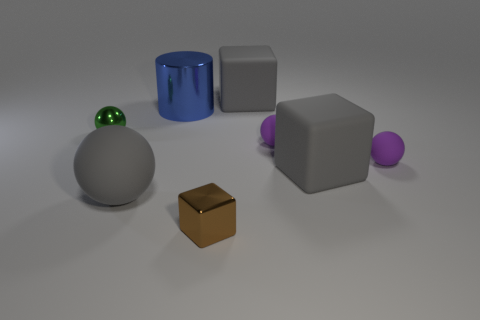There is a gray cube in front of the big blue shiny cylinder; is its size the same as the gray object that is behind the blue thing?
Make the answer very short. Yes. There is a small purple sphere on the left side of the gray block that is in front of the big metallic cylinder; what is it made of?
Your answer should be compact. Rubber. What number of objects are either spheres behind the large ball or large cylinders?
Make the answer very short. 4. Are there an equal number of large gray objects that are in front of the tiny green object and small brown metallic objects that are behind the large ball?
Your answer should be very brief. No. What is the material of the gray block that is behind the shiny object behind the tiny metallic ball that is behind the large gray ball?
Keep it short and to the point. Rubber. What is the size of the object that is left of the large blue cylinder and in front of the green shiny sphere?
Give a very brief answer. Large. What is the shape of the brown object that is made of the same material as the green sphere?
Your answer should be very brief. Cube. How many tiny things are either blue shiny things or red metallic spheres?
Your answer should be compact. 0. Is there a shiny ball right of the small object that is left of the gray ball?
Your response must be concise. No. Are there any gray matte things?
Give a very brief answer. Yes. 